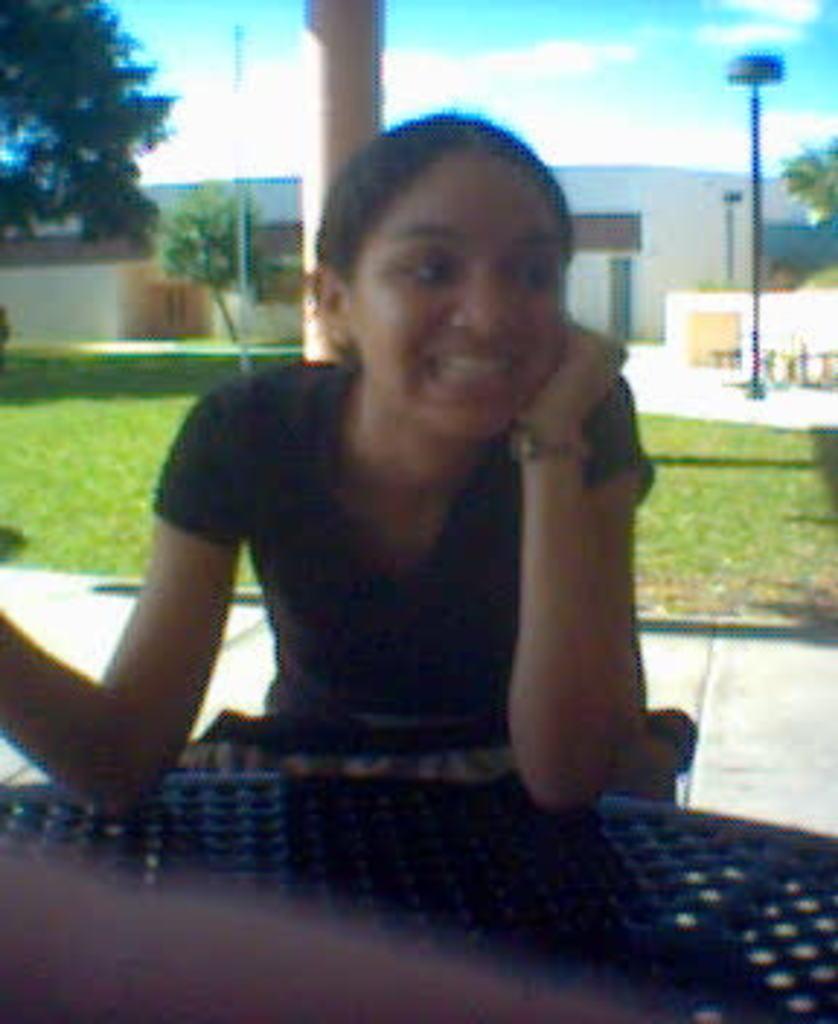How would you summarize this image in a sentence or two? In the image we can see a woman sitting, wearing clothes, wrist watch and she is smiling. Behind her we can see a building, trees, pole, pillar, grass and pale blue sky. 